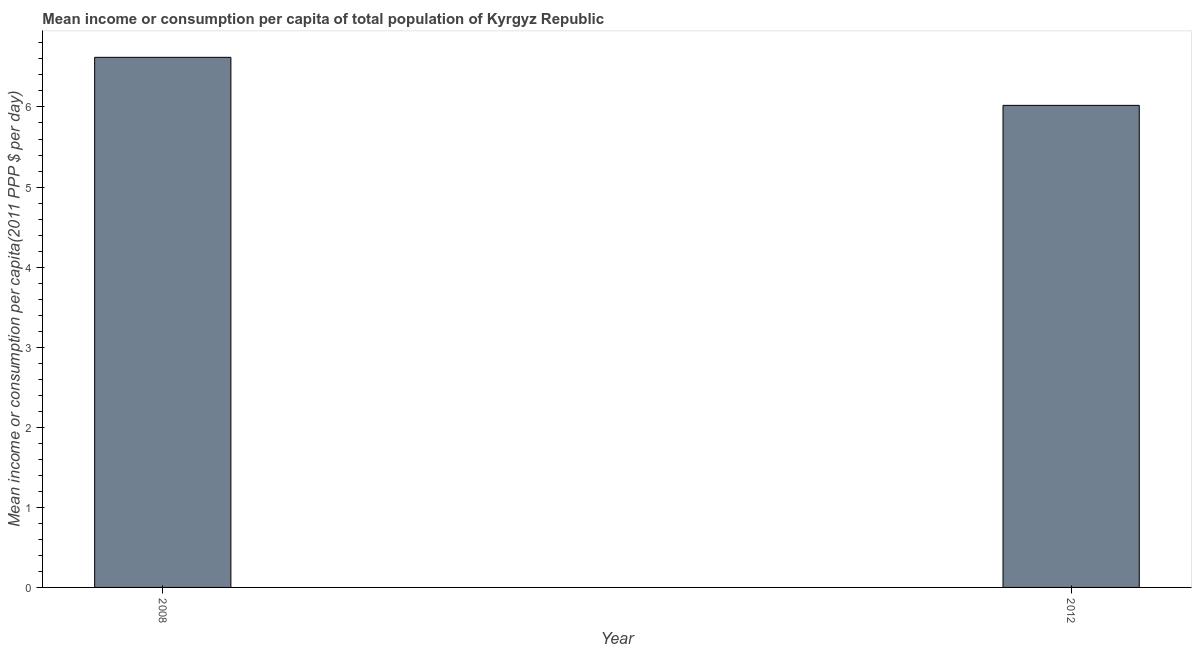Does the graph contain any zero values?
Give a very brief answer. No. What is the title of the graph?
Keep it short and to the point. Mean income or consumption per capita of total population of Kyrgyz Republic. What is the label or title of the Y-axis?
Make the answer very short. Mean income or consumption per capita(2011 PPP $ per day). What is the mean income or consumption in 2008?
Ensure brevity in your answer.  6.62. Across all years, what is the maximum mean income or consumption?
Provide a short and direct response. 6.62. Across all years, what is the minimum mean income or consumption?
Your answer should be compact. 6.02. In which year was the mean income or consumption maximum?
Offer a terse response. 2008. In which year was the mean income or consumption minimum?
Your answer should be compact. 2012. What is the sum of the mean income or consumption?
Provide a succinct answer. 12.64. What is the difference between the mean income or consumption in 2008 and 2012?
Provide a short and direct response. 0.6. What is the average mean income or consumption per year?
Offer a very short reply. 6.32. What is the median mean income or consumption?
Provide a short and direct response. 6.32. Is the mean income or consumption in 2008 less than that in 2012?
Make the answer very short. No. In how many years, is the mean income or consumption greater than the average mean income or consumption taken over all years?
Your answer should be very brief. 1. What is the Mean income or consumption per capita(2011 PPP $ per day) of 2008?
Ensure brevity in your answer.  6.62. What is the Mean income or consumption per capita(2011 PPP $ per day) in 2012?
Offer a terse response. 6.02. What is the difference between the Mean income or consumption per capita(2011 PPP $ per day) in 2008 and 2012?
Your answer should be very brief. 0.6. 